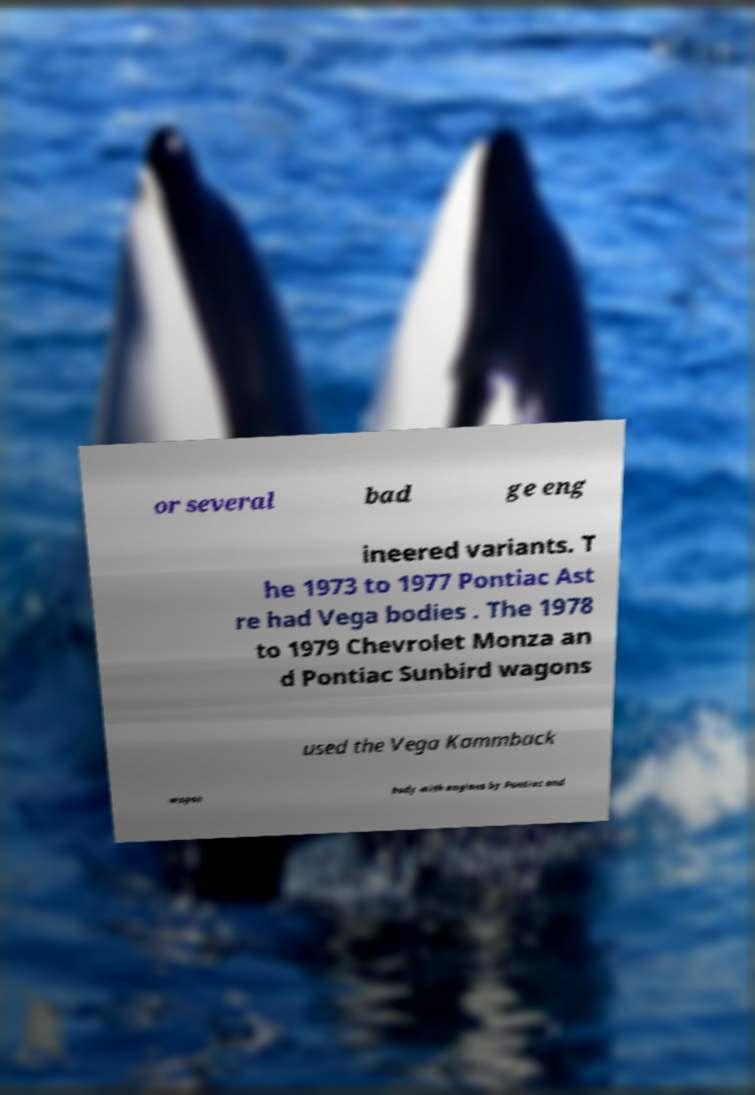Please identify and transcribe the text found in this image. or several bad ge eng ineered variants. T he 1973 to 1977 Pontiac Ast re had Vega bodies . The 1978 to 1979 Chevrolet Monza an d Pontiac Sunbird wagons used the Vega Kammback wagon body with engines by Pontiac and 